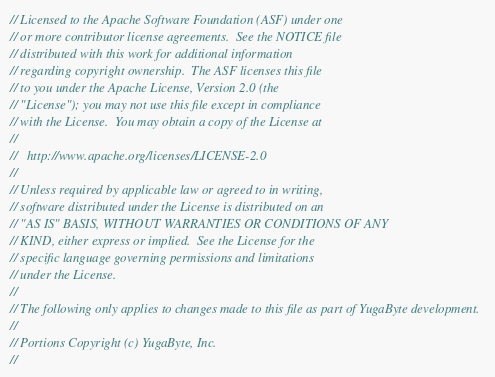<code> <loc_0><loc_0><loc_500><loc_500><_C++_>// Licensed to the Apache Software Foundation (ASF) under one
// or more contributor license agreements.  See the NOTICE file
// distributed with this work for additional information
// regarding copyright ownership.  The ASF licenses this file
// to you under the Apache License, Version 2.0 (the
// "License"); you may not use this file except in compliance
// with the License.  You may obtain a copy of the License at
//
//   http://www.apache.org/licenses/LICENSE-2.0
//
// Unless required by applicable law or agreed to in writing,
// software distributed under the License is distributed on an
// "AS IS" BASIS, WITHOUT WARRANTIES OR CONDITIONS OF ANY
// KIND, either express or implied.  See the License for the
// specific language governing permissions and limitations
// under the License.
//
// The following only applies to changes made to this file as part of YugaByte development.
//
// Portions Copyright (c) YugaByte, Inc.
//</code> 